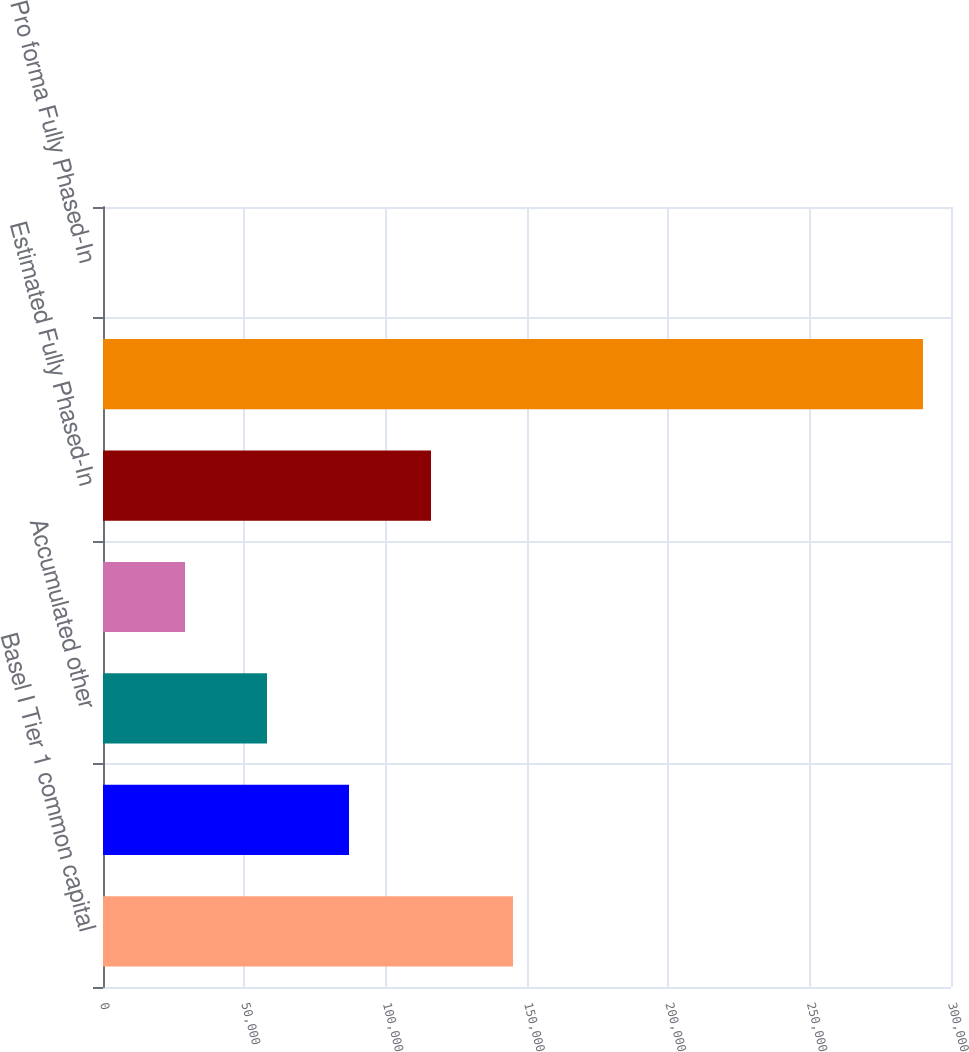Convert chart. <chart><loc_0><loc_0><loc_500><loc_500><bar_chart><fcel>Basel I Tier 1 common capital<fcel>Basel III quantitative limits<fcel>Accumulated other<fcel>All other adjustments<fcel>Estimated Fully Phased-In<fcel>Estimated Basel III advanced<fcel>Pro forma Fully Phased-In<nl><fcel>145045<fcel>87030.6<fcel>58023.6<fcel>29016.5<fcel>116038<fcel>290080<fcel>9.5<nl></chart> 